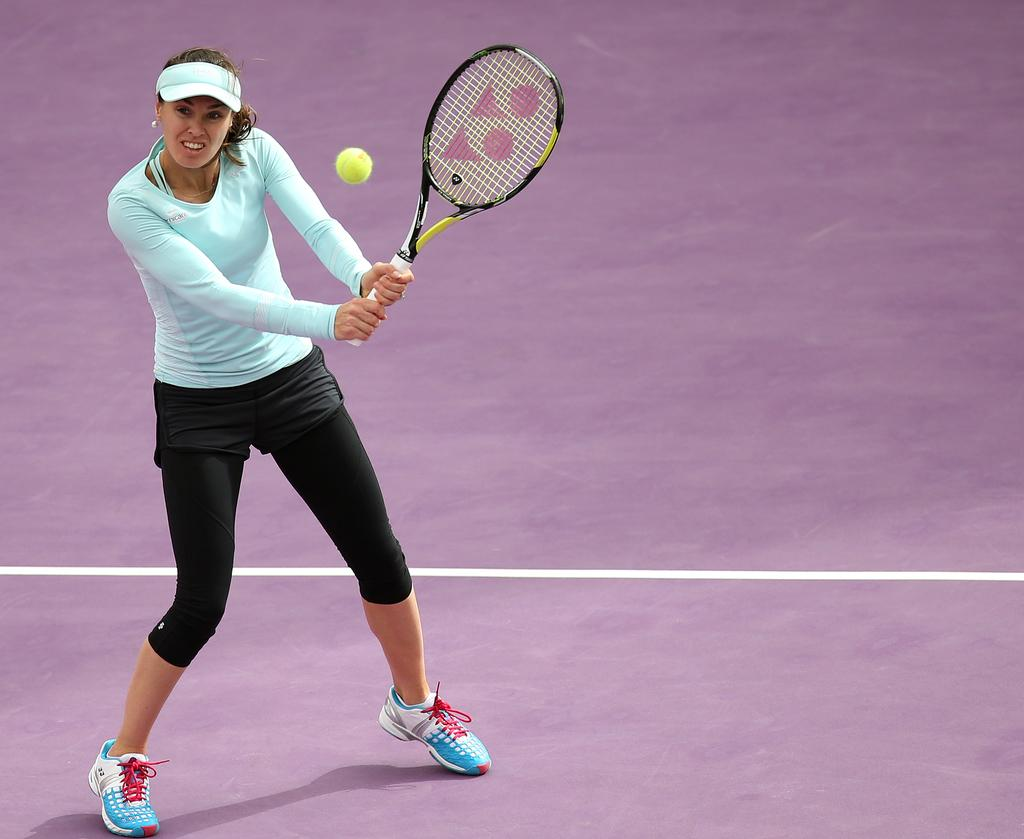Who is present in the image? There is a woman in the image. Where is the woman located in the image? The woman is standing on the bottom left side of the image. What is the woman holding in the image? The woman is holding a tennis racket. What other item related to tennis can be seen in the image? There is a tennis ball in the image. What type of underwear is the woman wearing in the image? There is no information about the woman's underwear in the image, so it cannot be determined. 